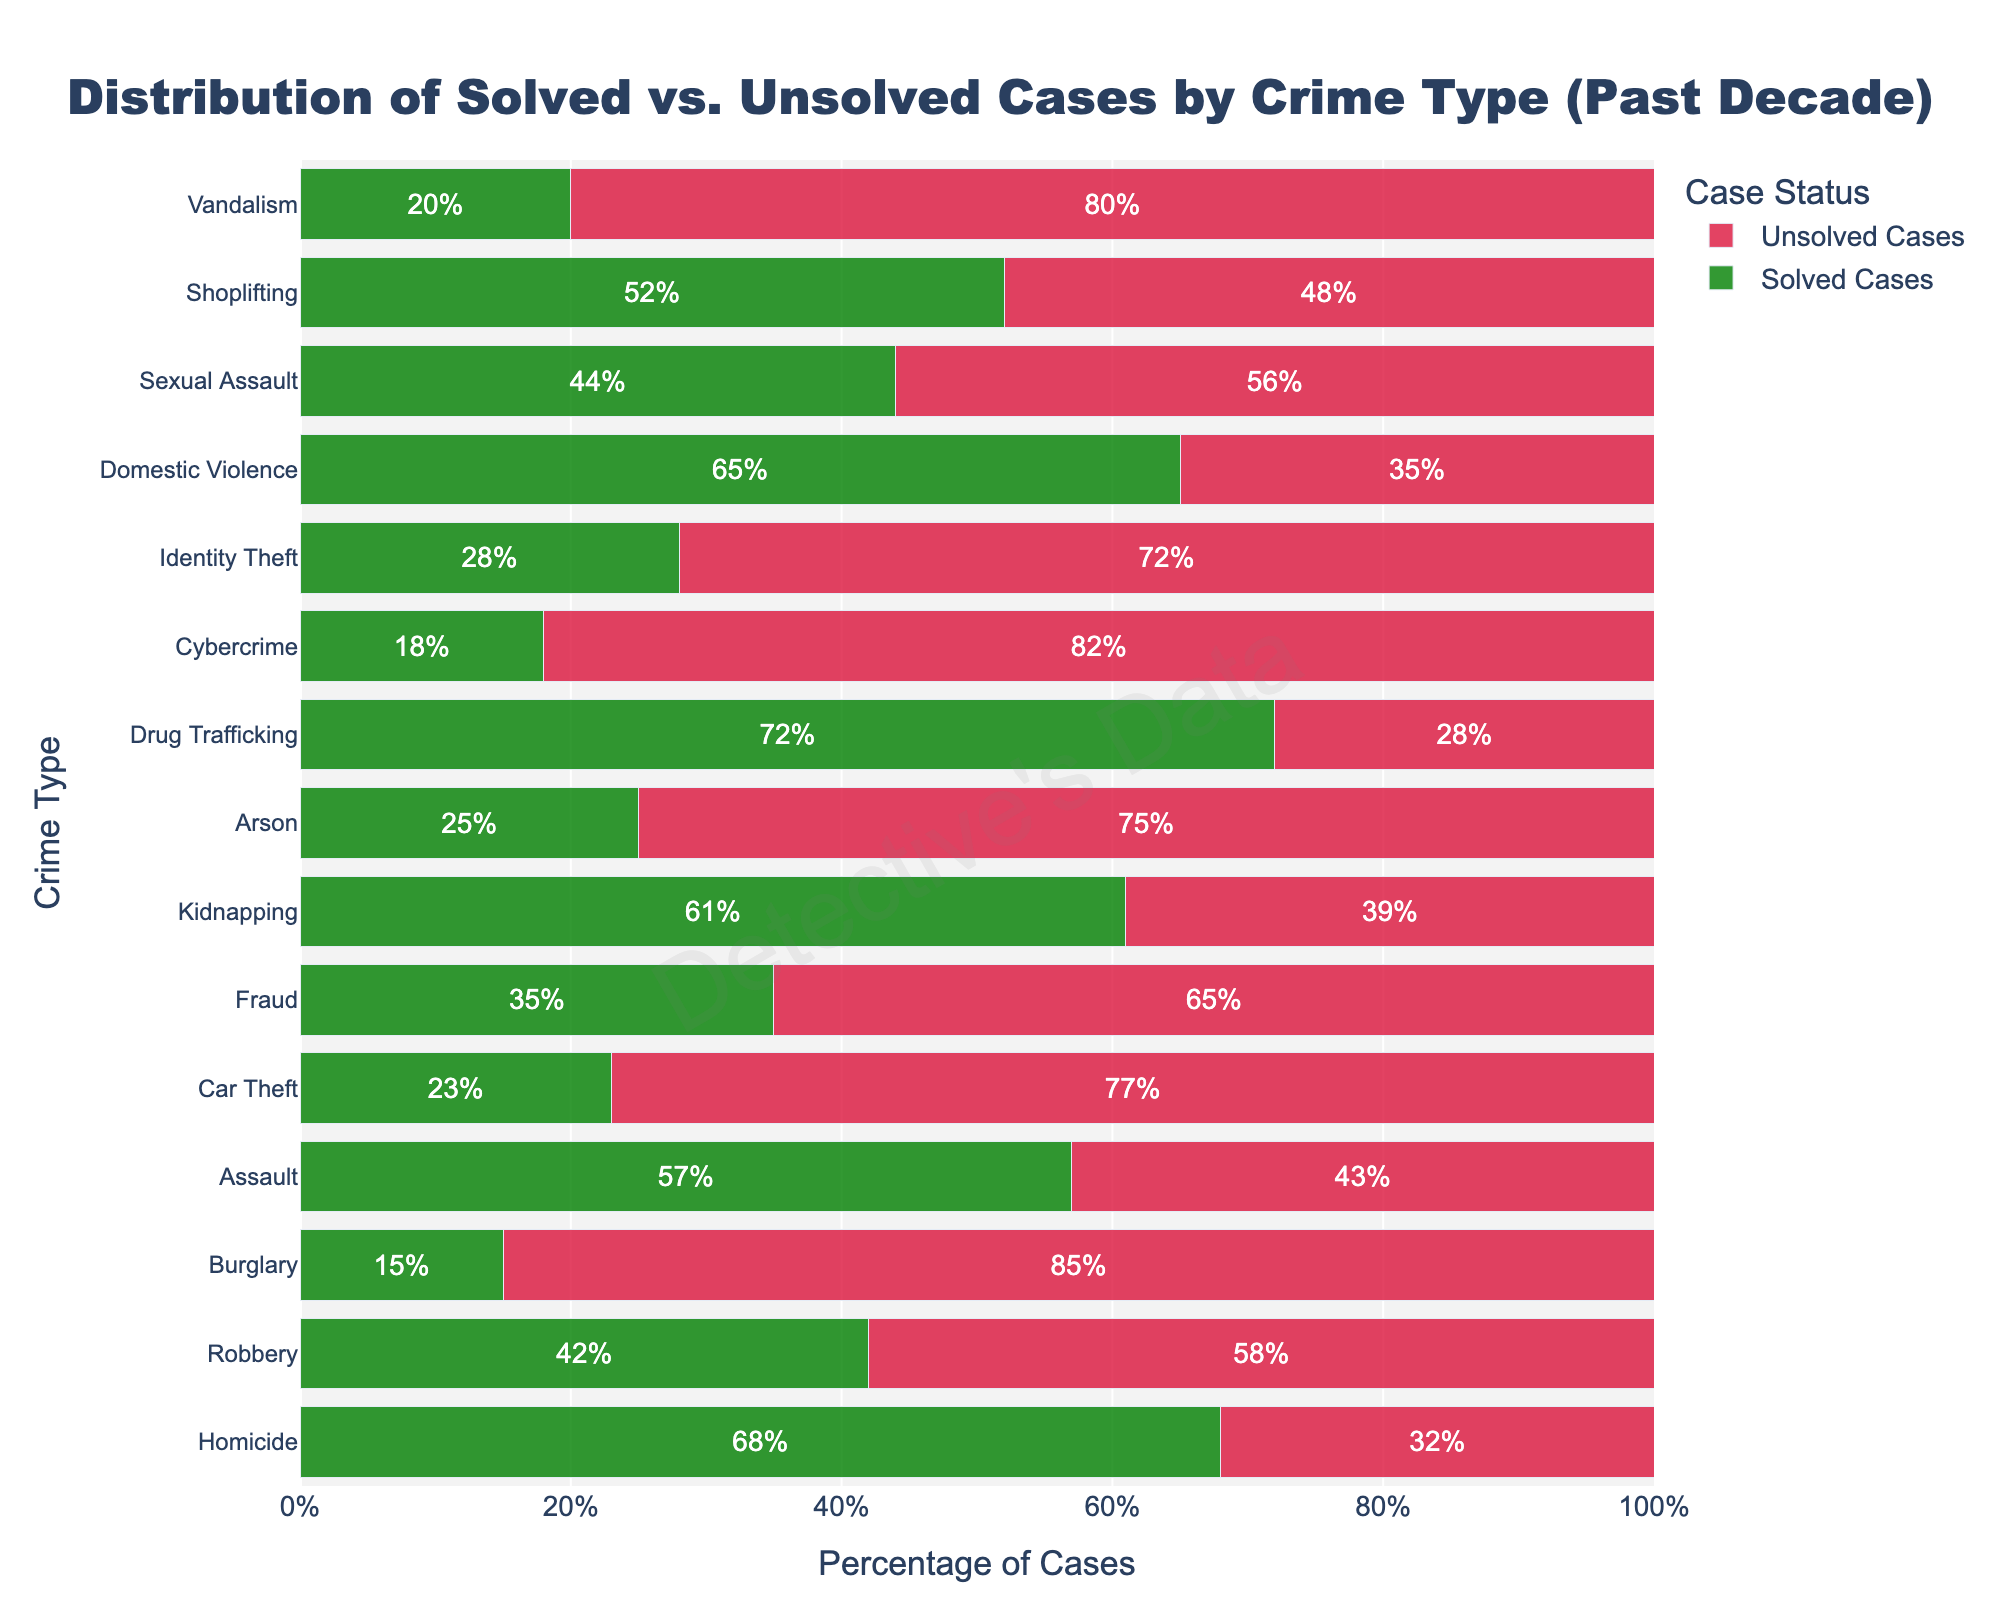Which crime type has the highest percentage of solved cases? To find the crime type with the highest percentage of solved cases, examine the lengths of the green bars in the chart. Drug Trafficking has the longest green bar with 72%.
Answer: Drug Trafficking Which crime type has the lowest percentage of solved cases? To identify the crime type with the lowest solved cases percentage, look for the shortest green bar. Burglary has the shortest green bar with only 15% solved cases.
Answer: Burglary Compare Burglary and Fraud in terms of solved and unsolved cases. Which crime type has a higher percentage of unsolved cases? To compare the two, check the lengths of the red bars for Burglary and Fraud. Burglary has 85% unsolved cases while Fraud has 65%. Hence, Burglary has a higher percentage of unsolved cases.
Answer: Burglary What is the average percentage of solved cases across all types of crimes? Calculate the average percentage of solved cases by summing each crime's solved percentage and dividing by the number of crime types. Sum: 68+42+15+57+23+35+61+25+72+18+28+65+44+52+20 = 625. Number of crime types: 15. Average = 625 / 15 = 41.67%.
Answer: 41.67% Which crime has a closer percentage of solved vs. unsolved cases? Look for bars where green and red parts are almost equal in length. For Shoplifting, values are 52% solved and 48% unsolved, making them very close.
Answer: Shoplifting What is the difference in the percentage of solved cases between Homicide and Cybercrime? Subtract the percentage of solved Cybercrime cases from solved Homicide cases. Difference: 68% - 18% = 50%.
Answer: 50% How do Car Theft and Vandalism compare in the percentage of solved cases? Look at the lengths of the green bars for Car Theft and Vandalism. Car Theft has 23% solved cases while Vandalism has 20% solved cases. Car Theft has a slightly higher solved case percentage.
Answer: Car Theft Arrange the crime types in ascending order based on the percentage of solved cases. Based on the green bars' lengths, list the crime types from shortest to longest green bars. Order: Burglary (15%), Cybercrime (18%), Vandalism (20%), Car Theft (23%), Arson (25%), Identity Theft (28%), Fraud (35%), Robbery (42%), Sexual Assault (44%), Shoplifting (52%), Assault (57%), Kidnapping (61%), Domestic Violence (65%), Homicide (68%), Drug Trafficking (72%).
Answer: Burglary, Cybercrime, Vandalism, Car Theft, Arson, Identity Theft, Fraud, Robbery, Sexual Assault, Shoplifting, Assault, Kidnapping, Domestic Violence, Homicide, Drug Trafficking 